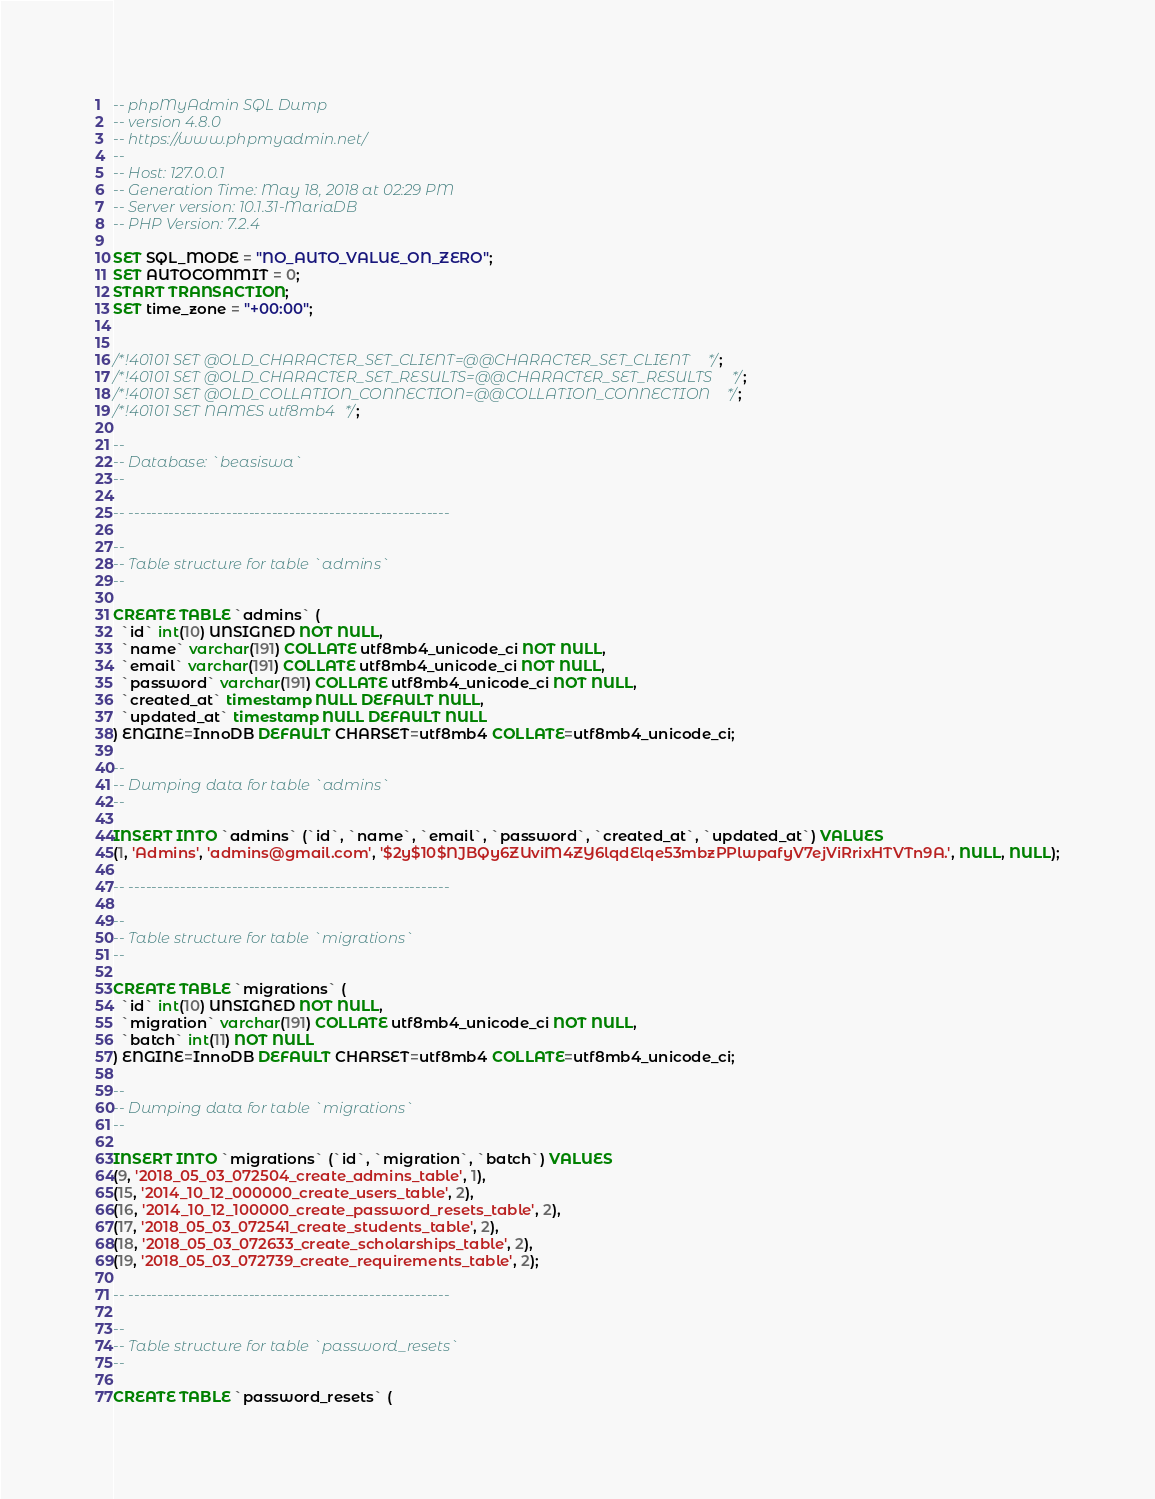Convert code to text. <code><loc_0><loc_0><loc_500><loc_500><_SQL_>-- phpMyAdmin SQL Dump
-- version 4.8.0
-- https://www.phpmyadmin.net/
--
-- Host: 127.0.0.1
-- Generation Time: May 18, 2018 at 02:29 PM
-- Server version: 10.1.31-MariaDB
-- PHP Version: 7.2.4

SET SQL_MODE = "NO_AUTO_VALUE_ON_ZERO";
SET AUTOCOMMIT = 0;
START TRANSACTION;
SET time_zone = "+00:00";


/*!40101 SET @OLD_CHARACTER_SET_CLIENT=@@CHARACTER_SET_CLIENT */;
/*!40101 SET @OLD_CHARACTER_SET_RESULTS=@@CHARACTER_SET_RESULTS */;
/*!40101 SET @OLD_COLLATION_CONNECTION=@@COLLATION_CONNECTION */;
/*!40101 SET NAMES utf8mb4 */;

--
-- Database: `beasiswa`
--

-- --------------------------------------------------------

--
-- Table structure for table `admins`
--

CREATE TABLE `admins` (
  `id` int(10) UNSIGNED NOT NULL,
  `name` varchar(191) COLLATE utf8mb4_unicode_ci NOT NULL,
  `email` varchar(191) COLLATE utf8mb4_unicode_ci NOT NULL,
  `password` varchar(191) COLLATE utf8mb4_unicode_ci NOT NULL,
  `created_at` timestamp NULL DEFAULT NULL,
  `updated_at` timestamp NULL DEFAULT NULL
) ENGINE=InnoDB DEFAULT CHARSET=utf8mb4 COLLATE=utf8mb4_unicode_ci;

--
-- Dumping data for table `admins`
--

INSERT INTO `admins` (`id`, `name`, `email`, `password`, `created_at`, `updated_at`) VALUES
(1, 'Admins', 'admins@gmail.com', '$2y$10$NJBQy6ZUviM4ZY6lqdElqe53mbzPPlwpafyV7ejViRrixHTVTn9A.', NULL, NULL);

-- --------------------------------------------------------

--
-- Table structure for table `migrations`
--

CREATE TABLE `migrations` (
  `id` int(10) UNSIGNED NOT NULL,
  `migration` varchar(191) COLLATE utf8mb4_unicode_ci NOT NULL,
  `batch` int(11) NOT NULL
) ENGINE=InnoDB DEFAULT CHARSET=utf8mb4 COLLATE=utf8mb4_unicode_ci;

--
-- Dumping data for table `migrations`
--

INSERT INTO `migrations` (`id`, `migration`, `batch`) VALUES
(9, '2018_05_03_072504_create_admins_table', 1),
(15, '2014_10_12_000000_create_users_table', 2),
(16, '2014_10_12_100000_create_password_resets_table', 2),
(17, '2018_05_03_072541_create_students_table', 2),
(18, '2018_05_03_072633_create_scholarships_table', 2),
(19, '2018_05_03_072739_create_requirements_table', 2);

-- --------------------------------------------------------

--
-- Table structure for table `password_resets`
--

CREATE TABLE `password_resets` (</code> 